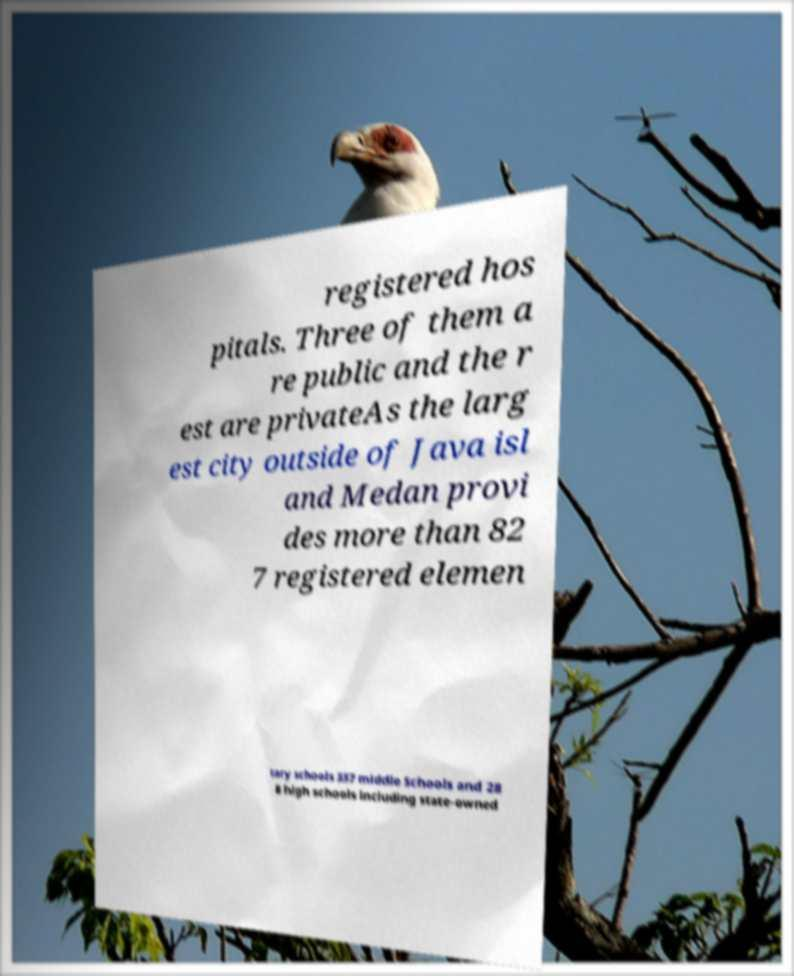Can you accurately transcribe the text from the provided image for me? registered hos pitals. Three of them a re public and the r est are privateAs the larg est city outside of Java isl and Medan provi des more than 82 7 registered elemen tary schools 337 middle Schools and 28 8 high schools including state-owned 